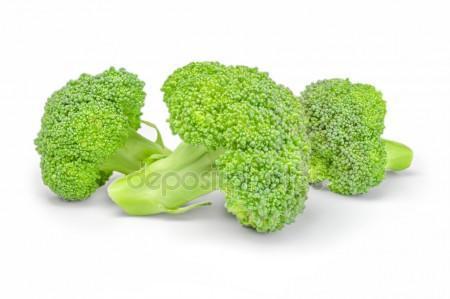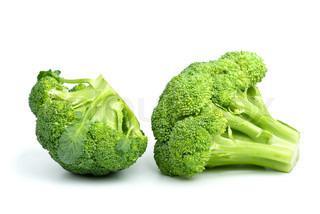The first image is the image on the left, the second image is the image on the right. Assess this claim about the two images: "A total of five cut broccoli florets are shown.". Correct or not? Answer yes or no. Yes. 